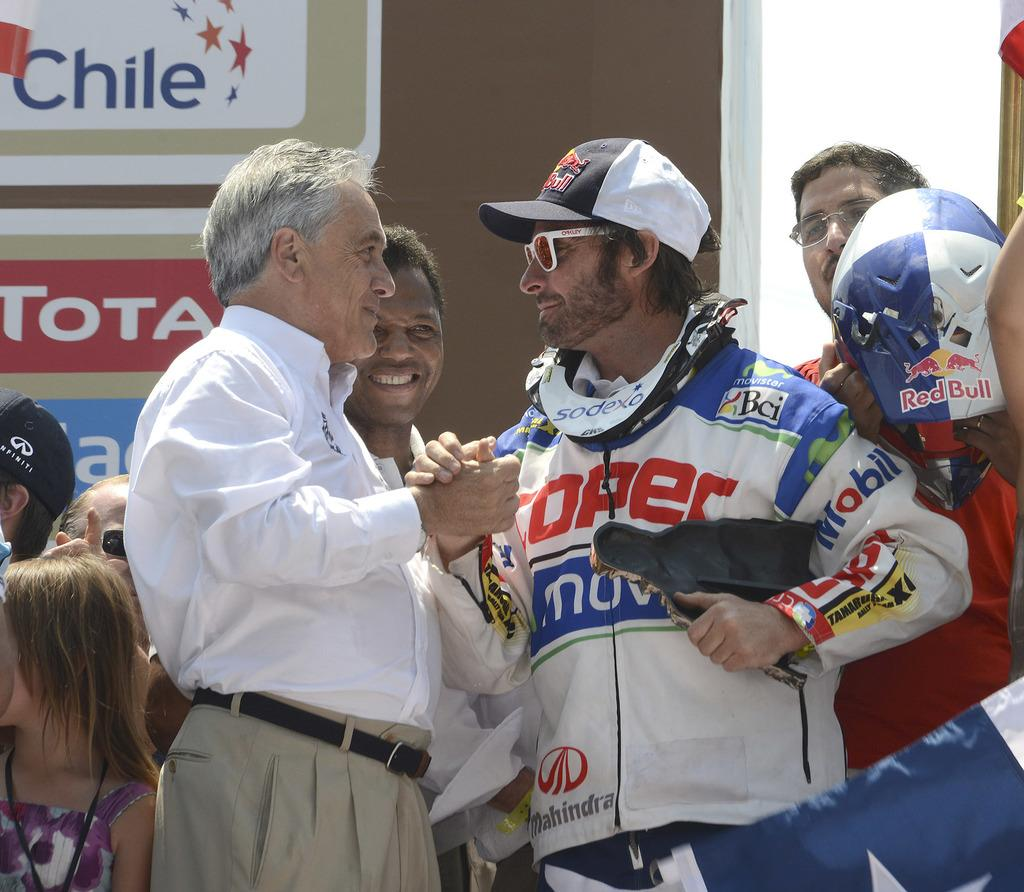Provide a one-sentence caption for the provided image. Two men shake hands in front oa sign that reads Chile. 